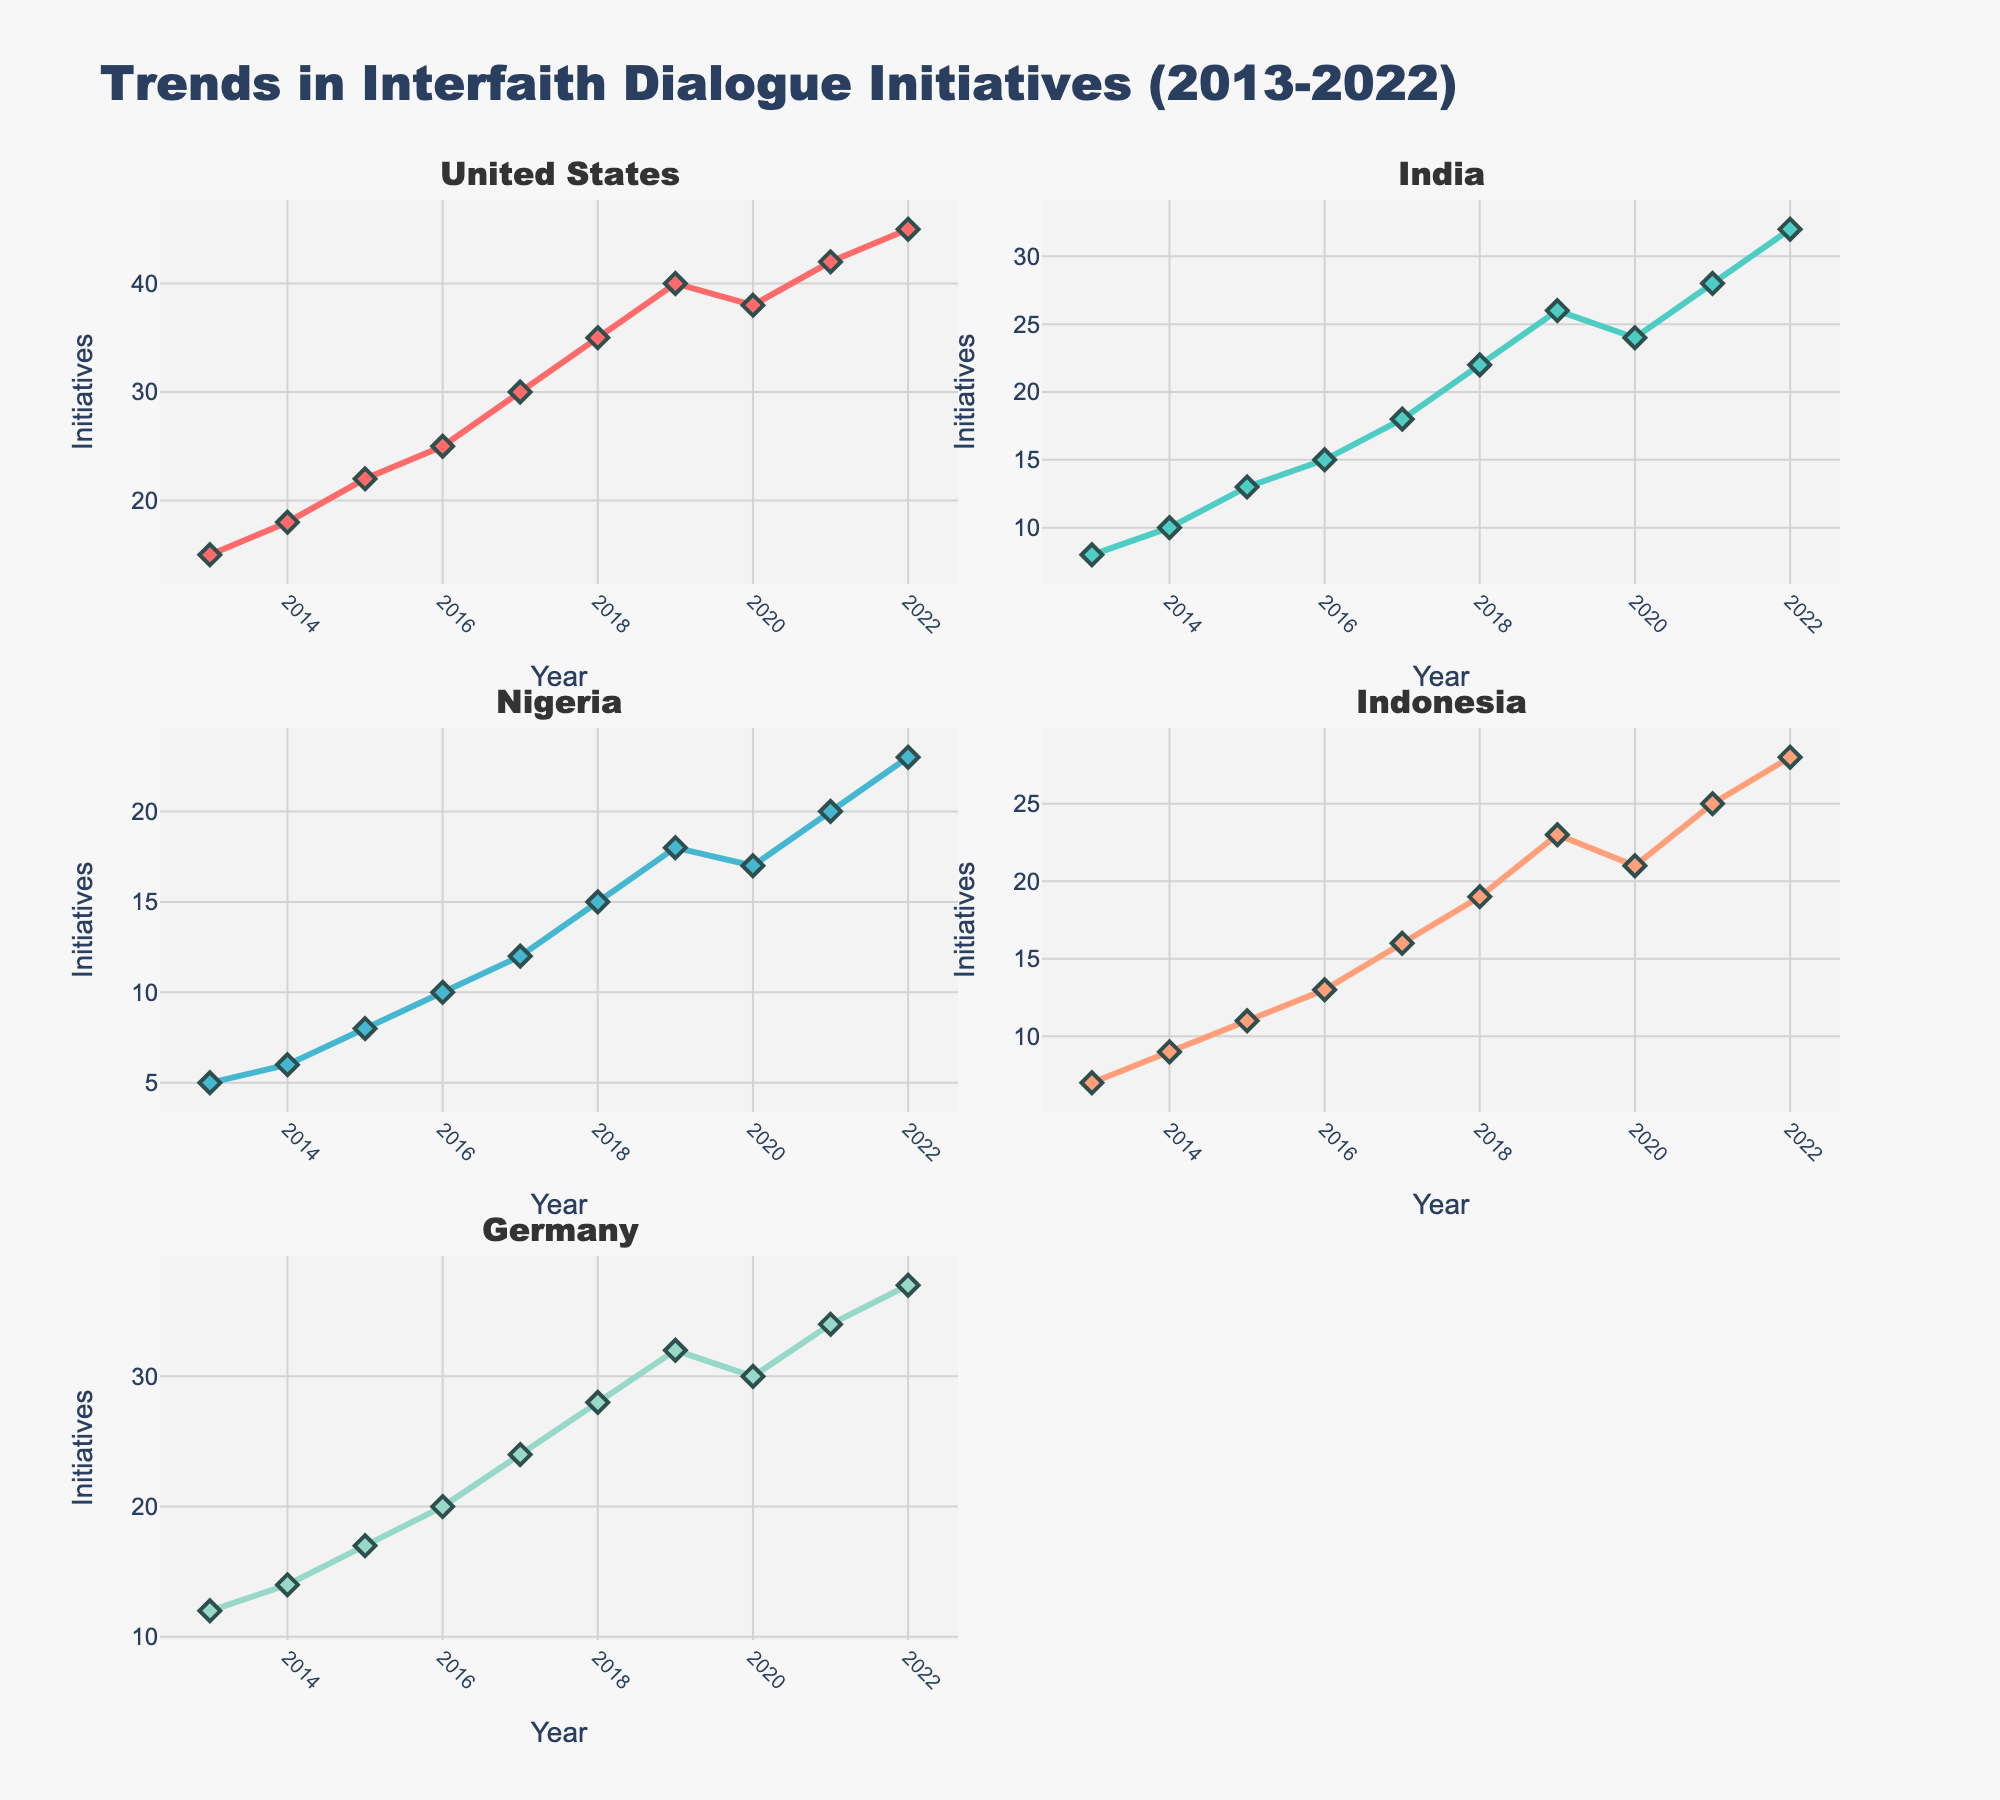How many countries are included in the figure? By looking at the subplot titles, we can see there are five subplots, each representing a different country.
Answer: 5 What is the title of the plot? The title is located at the top of the overall figure.
Answer: Trends in Interfaith Dialogue Initiatives (2013-2022) Which country had the highest number of interfaith dialogue initiatives in 2022? In 2022, we need to check the highest point on the y-axis in each subplot. The United States has the highest value.
Answer: United States How did the number of initiatives in Nigeria change from 2014 to 2020? From the subplot for Nigeria, for the years 2014 and 2020, we find the values for these years: 6 in 2014 and 17 in 2020. The change is calculated as 17 - 6.
Answer: Increased by 11 Which country saw the most consistent increase in initiatives over the decade? We compare the trends in each subplot. The United States shows a consistent upward trend every year.
Answer: United States Calculate the average number of initiatives in Indonesia over the decade. Sum the number of initiatives in Indonesia from 2013 to 2022 (7 + 9 + 11 + 13 + 16 + 19 + 23 + 21 + 25 + 28) and divide by the number of years (10). The total is 172, so the average is 172/10.
Answer: 17.2 By how much did the number of initiatives in Germany increase from 2013 to 2017? From the Germany subplot, the values are 12 in 2013 and 24 in 2017. The increase is calculated as 24 - 12.
Answer: 12 Which years saw a decrease in initiatives for the United States, if any? Check the subplot for the United States and look for years where the line decreases. The number decreased from 2019 to 2020.
Answer: 2019 to 2020 Compare the number of initiatives in 2016 between India and Germany. Which country had more, and by how much? From the subplots, India had 15 initiatives in 2016 and Germany had 20. Germany had more initiatives. The difference is 20 - 15.
Answer: Germany by 5 Which country had the lowest starting point in 2013 and what was the value? Check the y-axis for each subplot in 2013. Nigeria had the lowest starting point with 5 initiatives.
Answer: Nigeria, 5 